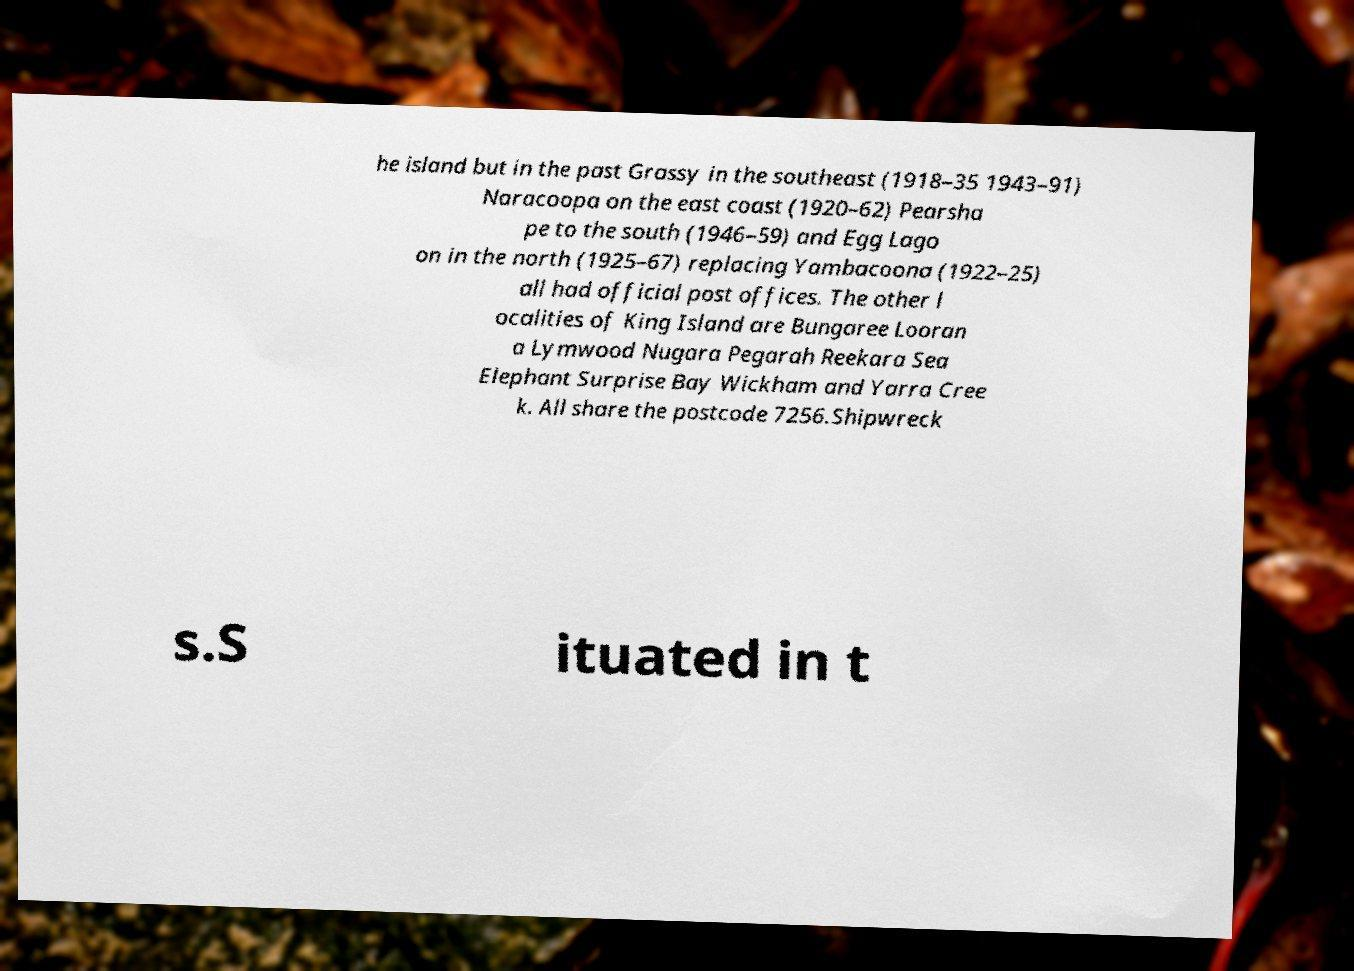Could you assist in decoding the text presented in this image and type it out clearly? he island but in the past Grassy in the southeast (1918–35 1943–91) Naracoopa on the east coast (1920–62) Pearsha pe to the south (1946–59) and Egg Lago on in the north (1925–67) replacing Yambacoona (1922–25) all had official post offices. The other l ocalities of King Island are Bungaree Looran a Lymwood Nugara Pegarah Reekara Sea Elephant Surprise Bay Wickham and Yarra Cree k. All share the postcode 7256.Shipwreck s.S ituated in t 